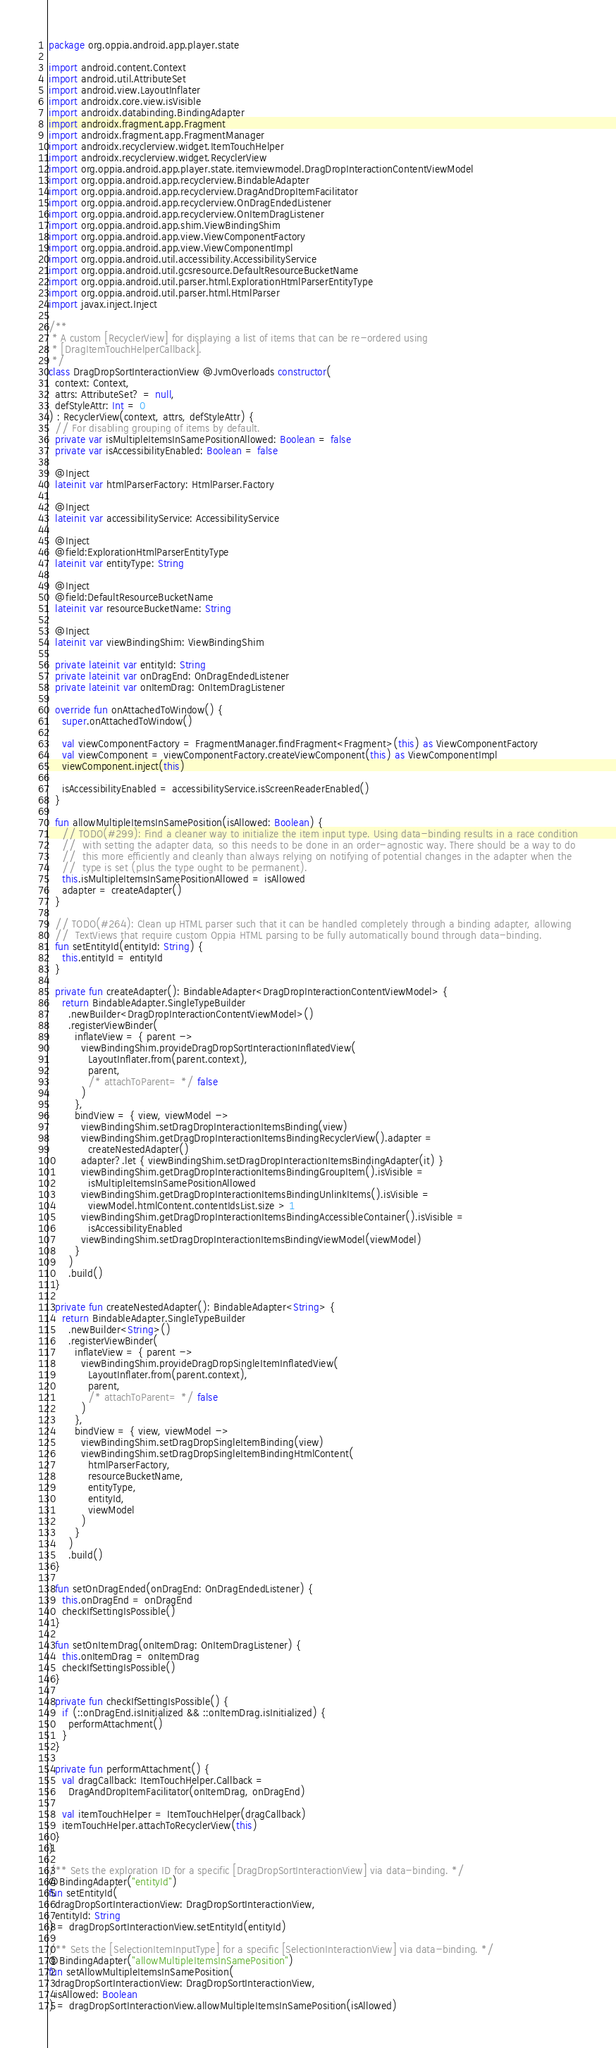Convert code to text. <code><loc_0><loc_0><loc_500><loc_500><_Kotlin_>package org.oppia.android.app.player.state

import android.content.Context
import android.util.AttributeSet
import android.view.LayoutInflater
import androidx.core.view.isVisible
import androidx.databinding.BindingAdapter
import androidx.fragment.app.Fragment
import androidx.fragment.app.FragmentManager
import androidx.recyclerview.widget.ItemTouchHelper
import androidx.recyclerview.widget.RecyclerView
import org.oppia.android.app.player.state.itemviewmodel.DragDropInteractionContentViewModel
import org.oppia.android.app.recyclerview.BindableAdapter
import org.oppia.android.app.recyclerview.DragAndDropItemFacilitator
import org.oppia.android.app.recyclerview.OnDragEndedListener
import org.oppia.android.app.recyclerview.OnItemDragListener
import org.oppia.android.app.shim.ViewBindingShim
import org.oppia.android.app.view.ViewComponentFactory
import org.oppia.android.app.view.ViewComponentImpl
import org.oppia.android.util.accessibility.AccessibilityService
import org.oppia.android.util.gcsresource.DefaultResourceBucketName
import org.oppia.android.util.parser.html.ExplorationHtmlParserEntityType
import org.oppia.android.util.parser.html.HtmlParser
import javax.inject.Inject

/**
 * A custom [RecyclerView] for displaying a list of items that can be re-ordered using
 * [DragItemTouchHelperCallback].
 */
class DragDropSortInteractionView @JvmOverloads constructor(
  context: Context,
  attrs: AttributeSet? = null,
  defStyleAttr: Int = 0
) : RecyclerView(context, attrs, defStyleAttr) {
  // For disabling grouping of items by default.
  private var isMultipleItemsInSamePositionAllowed: Boolean = false
  private var isAccessibilityEnabled: Boolean = false

  @Inject
  lateinit var htmlParserFactory: HtmlParser.Factory

  @Inject
  lateinit var accessibilityService: AccessibilityService

  @Inject
  @field:ExplorationHtmlParserEntityType
  lateinit var entityType: String

  @Inject
  @field:DefaultResourceBucketName
  lateinit var resourceBucketName: String

  @Inject
  lateinit var viewBindingShim: ViewBindingShim

  private lateinit var entityId: String
  private lateinit var onDragEnd: OnDragEndedListener
  private lateinit var onItemDrag: OnItemDragListener

  override fun onAttachedToWindow() {
    super.onAttachedToWindow()

    val viewComponentFactory = FragmentManager.findFragment<Fragment>(this) as ViewComponentFactory
    val viewComponent = viewComponentFactory.createViewComponent(this) as ViewComponentImpl
    viewComponent.inject(this)

    isAccessibilityEnabled = accessibilityService.isScreenReaderEnabled()
  }

  fun allowMultipleItemsInSamePosition(isAllowed: Boolean) {
    // TODO(#299): Find a cleaner way to initialize the item input type. Using data-binding results in a race condition
    //  with setting the adapter data, so this needs to be done in an order-agnostic way. There should be a way to do
    //  this more efficiently and cleanly than always relying on notifying of potential changes in the adapter when the
    //  type is set (plus the type ought to be permanent).
    this.isMultipleItemsInSamePositionAllowed = isAllowed
    adapter = createAdapter()
  }

  // TODO(#264): Clean up HTML parser such that it can be handled completely through a binding adapter, allowing
  //  TextViews that require custom Oppia HTML parsing to be fully automatically bound through data-binding.
  fun setEntityId(entityId: String) {
    this.entityId = entityId
  }

  private fun createAdapter(): BindableAdapter<DragDropInteractionContentViewModel> {
    return BindableAdapter.SingleTypeBuilder
      .newBuilder<DragDropInteractionContentViewModel>()
      .registerViewBinder(
        inflateView = { parent ->
          viewBindingShim.provideDragDropSortInteractionInflatedView(
            LayoutInflater.from(parent.context),
            parent,
            /* attachToParent= */ false
          )
        },
        bindView = { view, viewModel ->
          viewBindingShim.setDragDropInteractionItemsBinding(view)
          viewBindingShim.getDragDropInteractionItemsBindingRecyclerView().adapter =
            createNestedAdapter()
          adapter?.let { viewBindingShim.setDragDropInteractionItemsBindingAdapter(it) }
          viewBindingShim.getDragDropInteractionItemsBindingGroupItem().isVisible =
            isMultipleItemsInSamePositionAllowed
          viewBindingShim.getDragDropInteractionItemsBindingUnlinkItems().isVisible =
            viewModel.htmlContent.contentIdsList.size > 1
          viewBindingShim.getDragDropInteractionItemsBindingAccessibleContainer().isVisible =
            isAccessibilityEnabled
          viewBindingShim.setDragDropInteractionItemsBindingViewModel(viewModel)
        }
      )
      .build()
  }

  private fun createNestedAdapter(): BindableAdapter<String> {
    return BindableAdapter.SingleTypeBuilder
      .newBuilder<String>()
      .registerViewBinder(
        inflateView = { parent ->
          viewBindingShim.provideDragDropSingleItemInflatedView(
            LayoutInflater.from(parent.context),
            parent,
            /* attachToParent= */ false
          )
        },
        bindView = { view, viewModel ->
          viewBindingShim.setDragDropSingleItemBinding(view)
          viewBindingShim.setDragDropSingleItemBindingHtmlContent(
            htmlParserFactory,
            resourceBucketName,
            entityType,
            entityId,
            viewModel
          )
        }
      )
      .build()
  }

  fun setOnDragEnded(onDragEnd: OnDragEndedListener) {
    this.onDragEnd = onDragEnd
    checkIfSettingIsPossible()
  }

  fun setOnItemDrag(onItemDrag: OnItemDragListener) {
    this.onItemDrag = onItemDrag
    checkIfSettingIsPossible()
  }

  private fun checkIfSettingIsPossible() {
    if (::onDragEnd.isInitialized && ::onItemDrag.isInitialized) {
      performAttachment()
    }
  }

  private fun performAttachment() {
    val dragCallback: ItemTouchHelper.Callback =
      DragAndDropItemFacilitator(onItemDrag, onDragEnd)

    val itemTouchHelper = ItemTouchHelper(dragCallback)
    itemTouchHelper.attachToRecyclerView(this)
  }
}

/** Sets the exploration ID for a specific [DragDropSortInteractionView] via data-binding. */
@BindingAdapter("entityId")
fun setEntityId(
  dragDropSortInteractionView: DragDropSortInteractionView,
  entityId: String
) = dragDropSortInteractionView.setEntityId(entityId)

/** Sets the [SelectionItemInputType] for a specific [SelectionInteractionView] via data-binding. */
@BindingAdapter("allowMultipleItemsInSamePosition")
fun setAllowMultipleItemsInSamePosition(
  dragDropSortInteractionView: DragDropSortInteractionView,
  isAllowed: Boolean
) = dragDropSortInteractionView.allowMultipleItemsInSamePosition(isAllowed)
</code> 